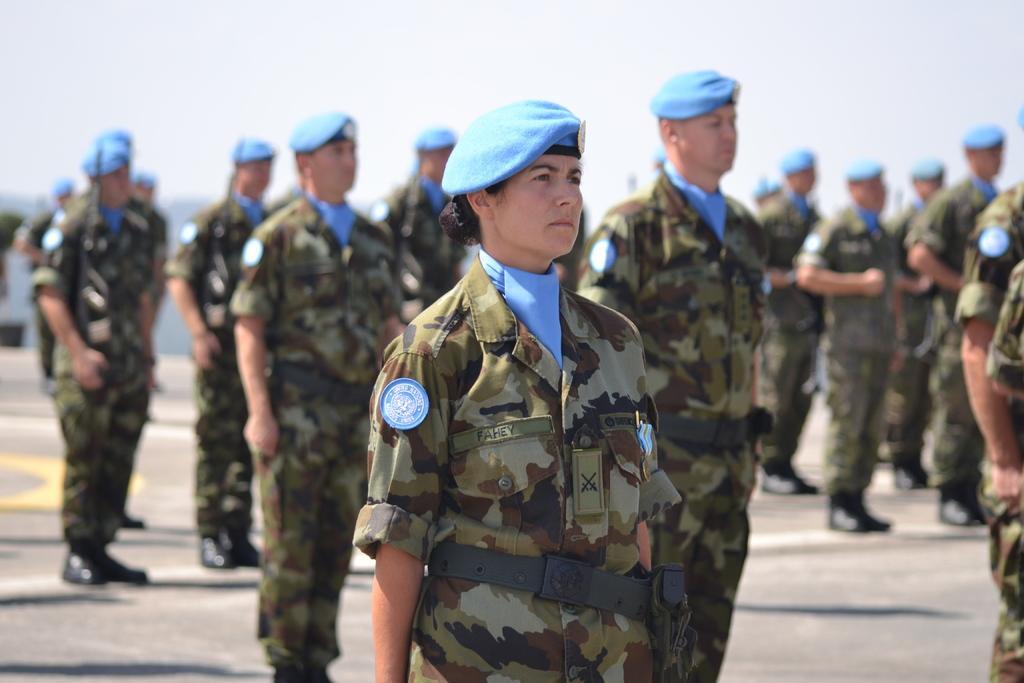Describe this image in one or two sentences. In this picture I can see in the middle there is a woman, she is wearing dress, cap. In the background a group of men are standing, at the top there is the sky. 